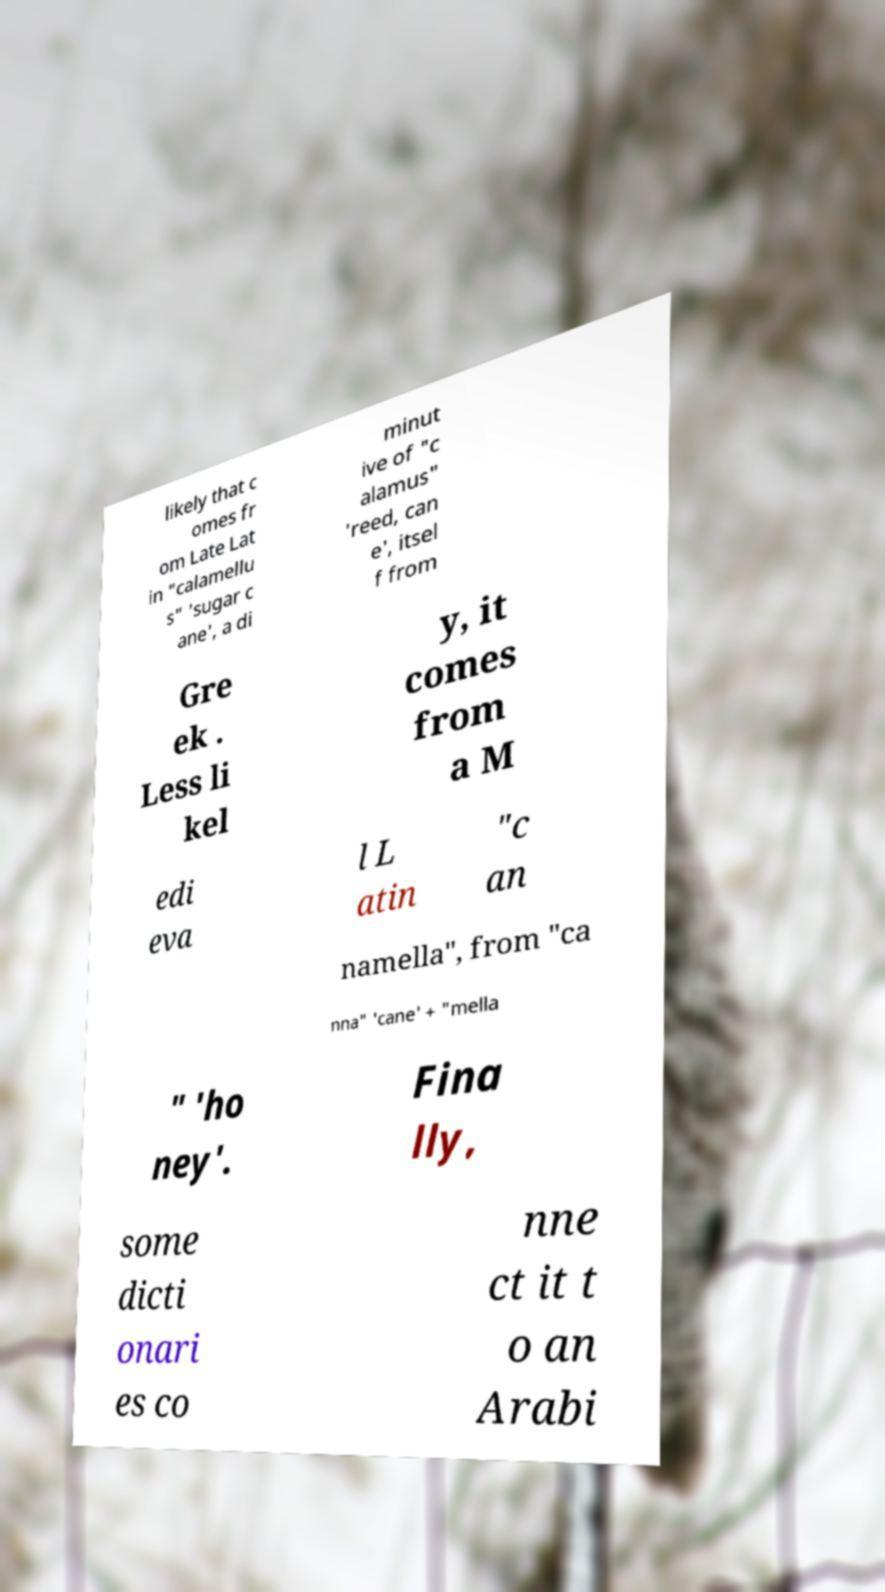Can you accurately transcribe the text from the provided image for me? likely that c omes fr om Late Lat in "calamellu s" 'sugar c ane', a di minut ive of "c alamus" 'reed, can e', itsel f from Gre ek . Less li kel y, it comes from a M edi eva l L atin "c an namella", from "ca nna" 'cane' + "mella " 'ho ney'. Fina lly, some dicti onari es co nne ct it t o an Arabi 